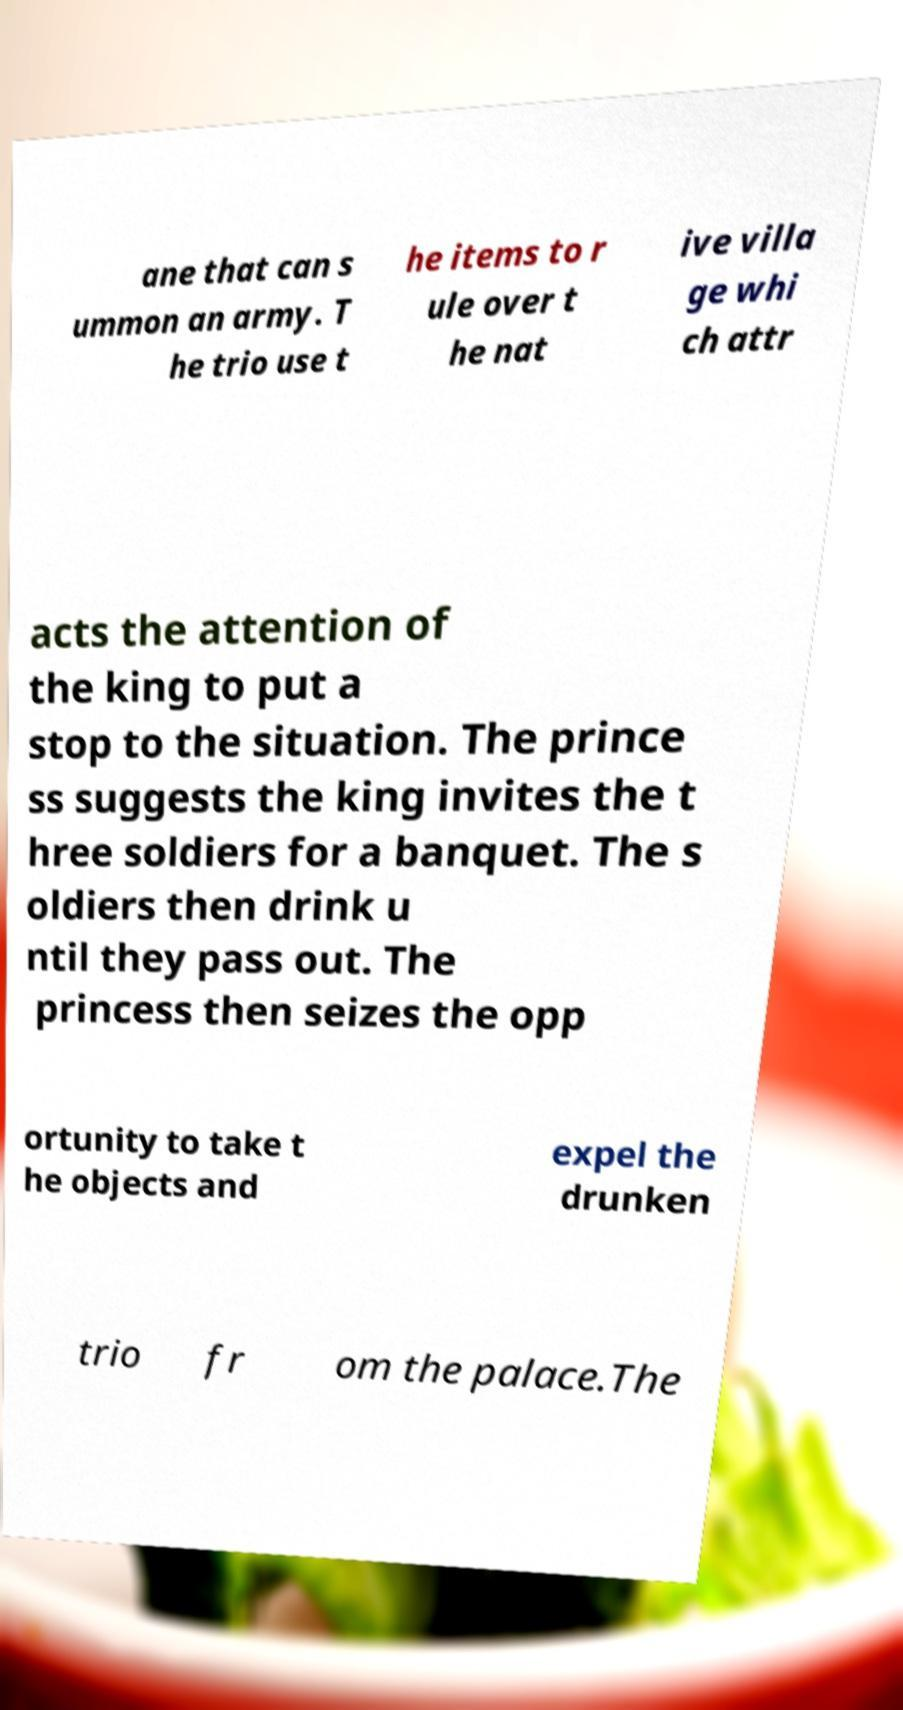There's text embedded in this image that I need extracted. Can you transcribe it verbatim? ane that can s ummon an army. T he trio use t he items to r ule over t he nat ive villa ge whi ch attr acts the attention of the king to put a stop to the situation. The prince ss suggests the king invites the t hree soldiers for a banquet. The s oldiers then drink u ntil they pass out. The princess then seizes the opp ortunity to take t he objects and expel the drunken trio fr om the palace.The 